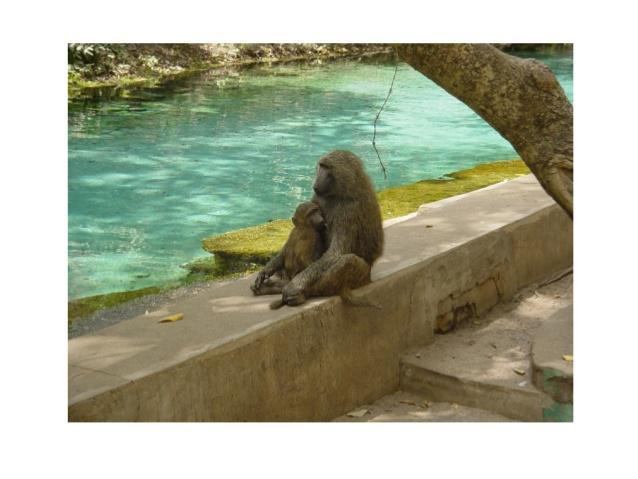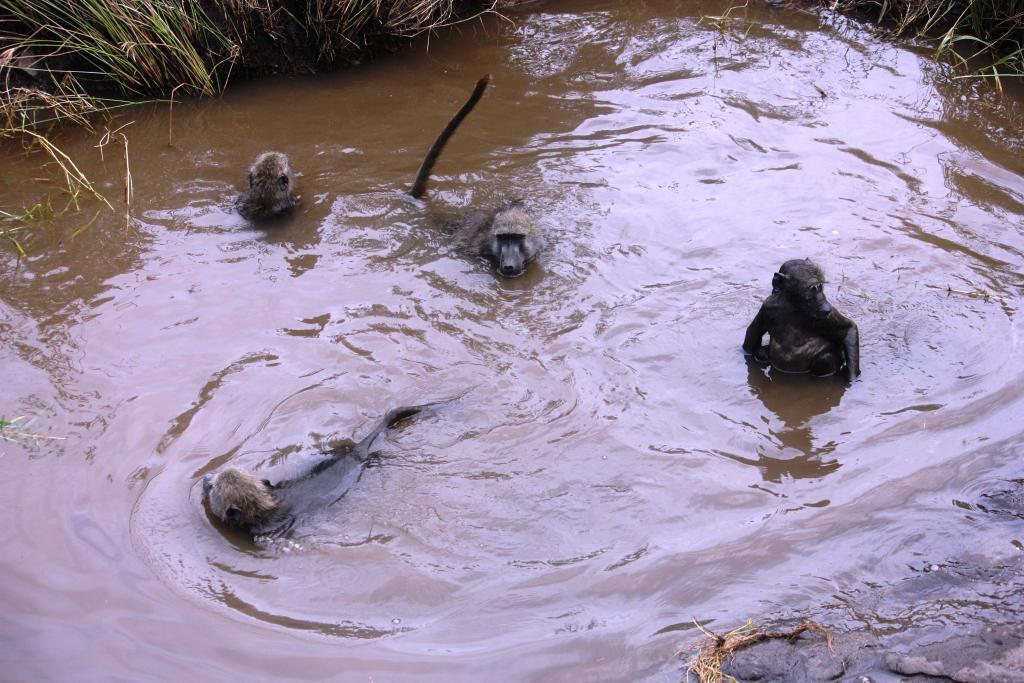The first image is the image on the left, the second image is the image on the right. Examine the images to the left and right. Is the description "The left image includes at least one baboon perched on a cement ledge next to water, and the right image includes at least one baboon neck-deep in water." accurate? Answer yes or no. Yes. 